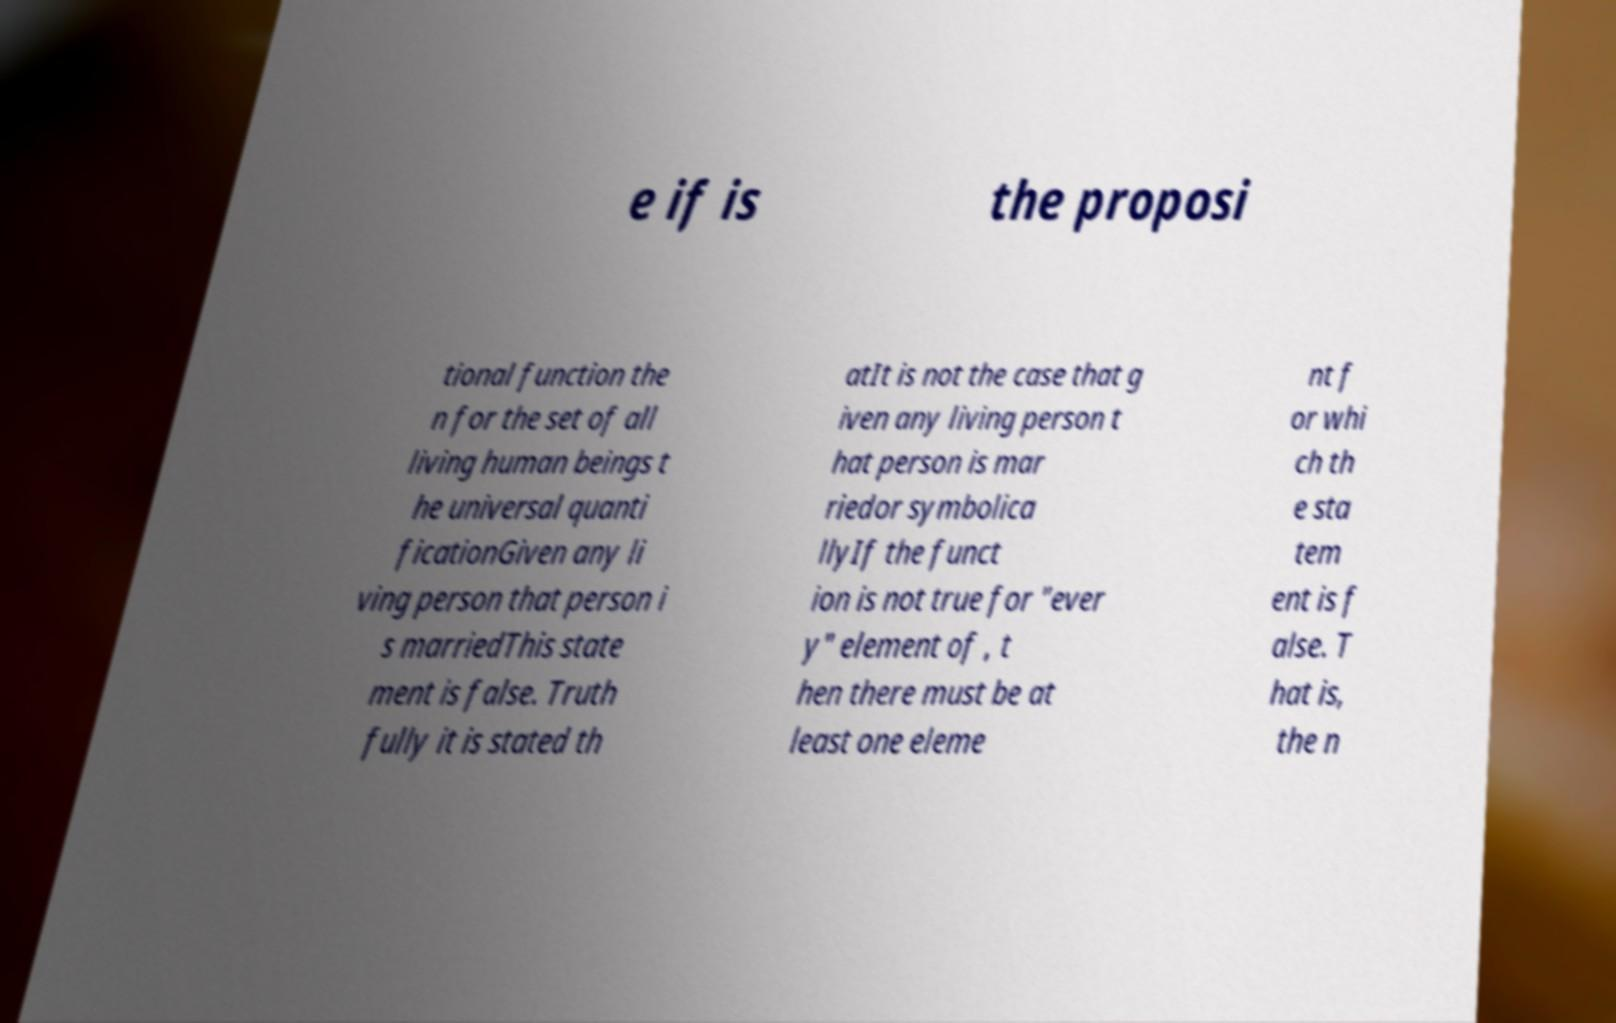Could you assist in decoding the text presented in this image and type it out clearly? e if is the proposi tional function the n for the set of all living human beings t he universal quanti ficationGiven any li ving person that person i s marriedThis state ment is false. Truth fully it is stated th atIt is not the case that g iven any living person t hat person is mar riedor symbolica llyIf the funct ion is not true for "ever y" element of , t hen there must be at least one eleme nt f or whi ch th e sta tem ent is f alse. T hat is, the n 